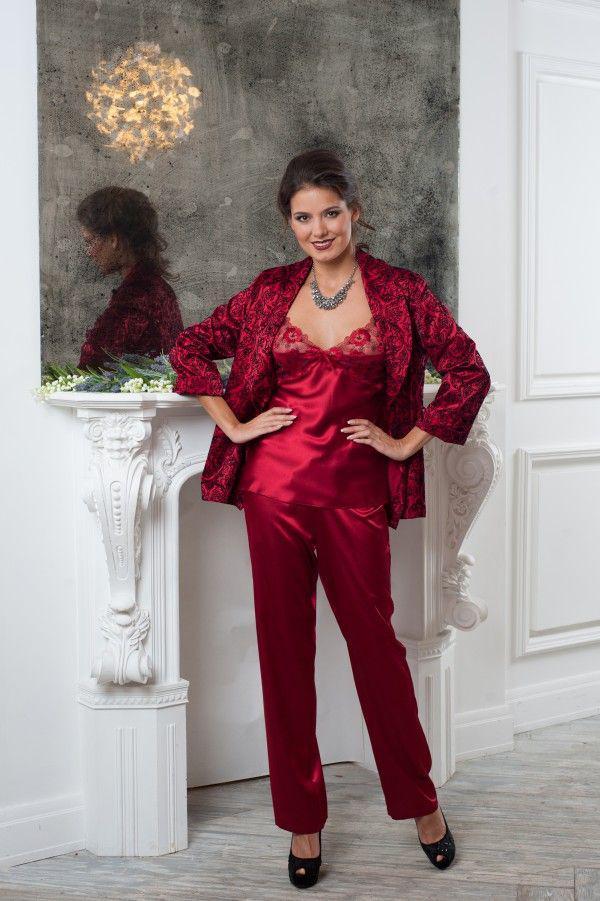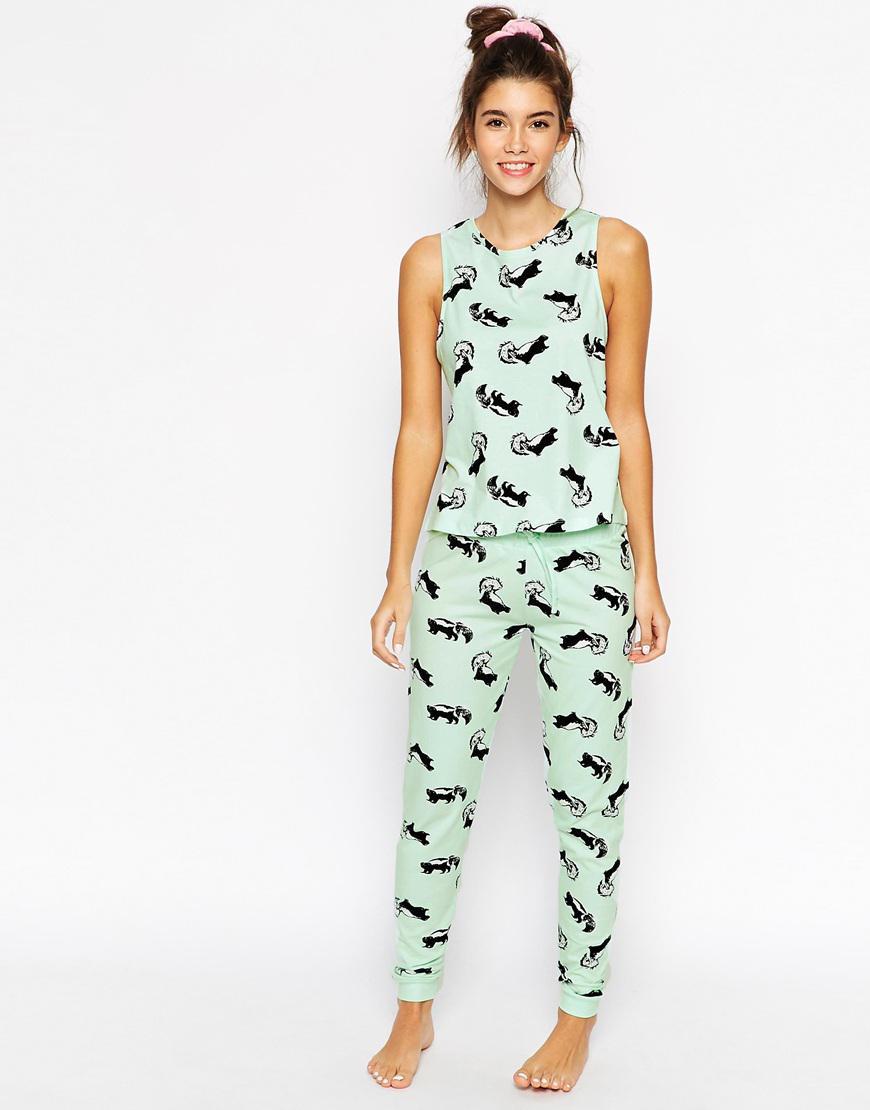The first image is the image on the left, the second image is the image on the right. Examine the images to the left and right. Is the description "In one image, a woman is wearing purple pajamas" accurate? Answer yes or no. No. 